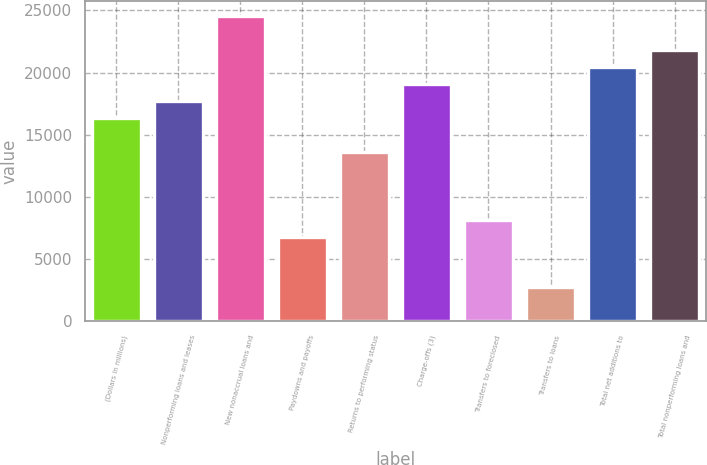Convert chart to OTSL. <chart><loc_0><loc_0><loc_500><loc_500><bar_chart><fcel>(Dollars in millions)<fcel>Nonperforming loans and leases<fcel>New nonaccrual loans and<fcel>Paydowns and payoffs<fcel>Returns to performing status<fcel>Charge-offs (3)<fcel>Transfers to foreclosed<fcel>Transfers to loans<fcel>Total net additions to<fcel>Total nonperforming loans and<nl><fcel>16349.6<fcel>17712<fcel>24523.6<fcel>6813.33<fcel>13625<fcel>19074.3<fcel>8175.66<fcel>2726.34<fcel>20436.6<fcel>21799<nl></chart> 